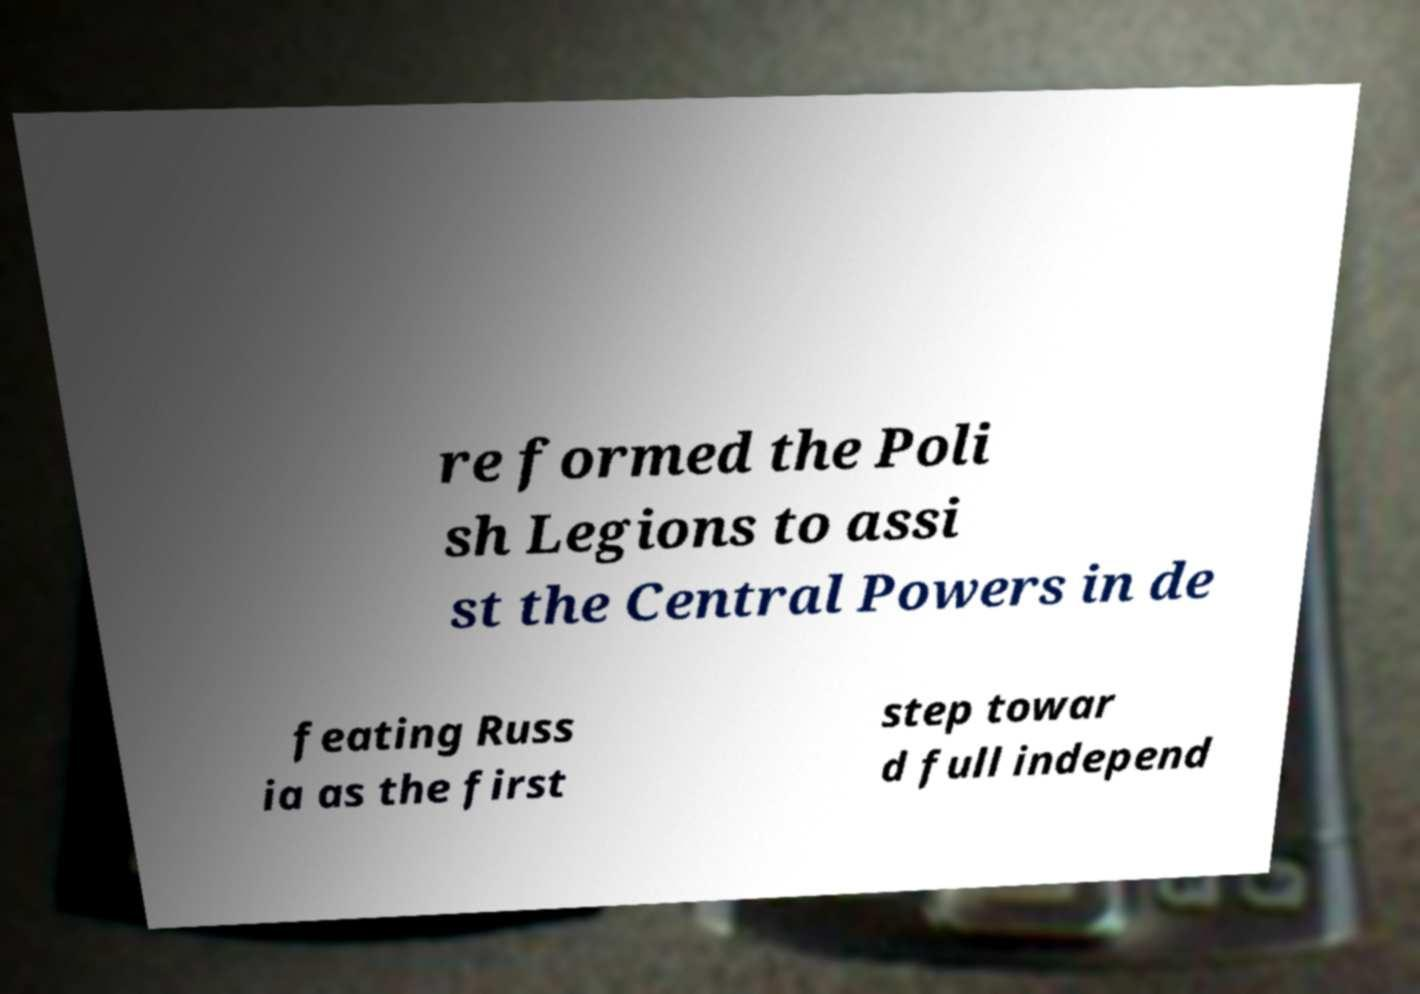Can you accurately transcribe the text from the provided image for me? re formed the Poli sh Legions to assi st the Central Powers in de feating Russ ia as the first step towar d full independ 